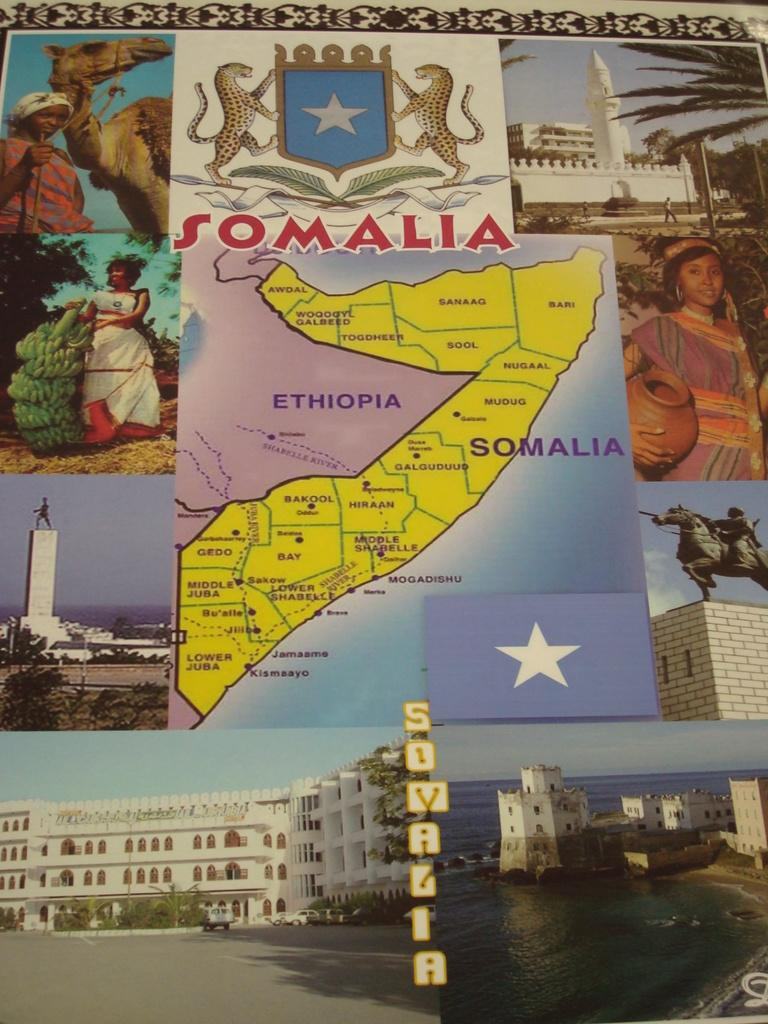<image>
Present a compact description of the photo's key features. A map of Somalia surrounded by pictures from the country. 